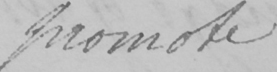Can you tell me what this handwritten text says? promote 